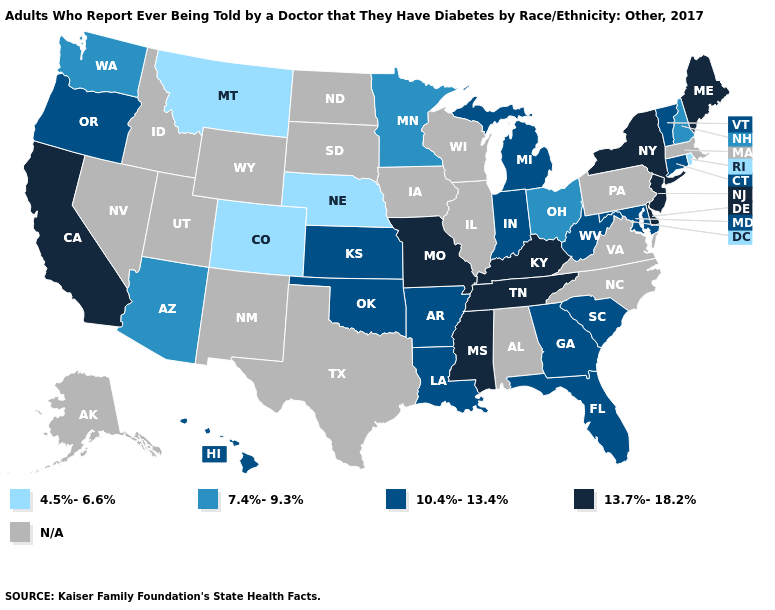Which states hav the highest value in the Northeast?
Concise answer only. Maine, New Jersey, New York. Name the states that have a value in the range 4.5%-6.6%?
Concise answer only. Colorado, Montana, Nebraska, Rhode Island. Does the first symbol in the legend represent the smallest category?
Answer briefly. Yes. What is the highest value in states that border North Carolina?
Concise answer only. 13.7%-18.2%. Which states have the lowest value in the USA?
Concise answer only. Colorado, Montana, Nebraska, Rhode Island. Does the map have missing data?
Write a very short answer. Yes. Name the states that have a value in the range 7.4%-9.3%?
Give a very brief answer. Arizona, Minnesota, New Hampshire, Ohio, Washington. Which states hav the highest value in the Northeast?
Answer briefly. Maine, New Jersey, New York. Does Montana have the lowest value in the USA?
Be succinct. Yes. Name the states that have a value in the range N/A?
Keep it brief. Alabama, Alaska, Idaho, Illinois, Iowa, Massachusetts, Nevada, New Mexico, North Carolina, North Dakota, Pennsylvania, South Dakota, Texas, Utah, Virginia, Wisconsin, Wyoming. What is the value of Rhode Island?
Be succinct. 4.5%-6.6%. Does New Hampshire have the highest value in the Northeast?
Keep it brief. No. What is the lowest value in the West?
Quick response, please. 4.5%-6.6%. What is the value of South Dakota?
Concise answer only. N/A. 